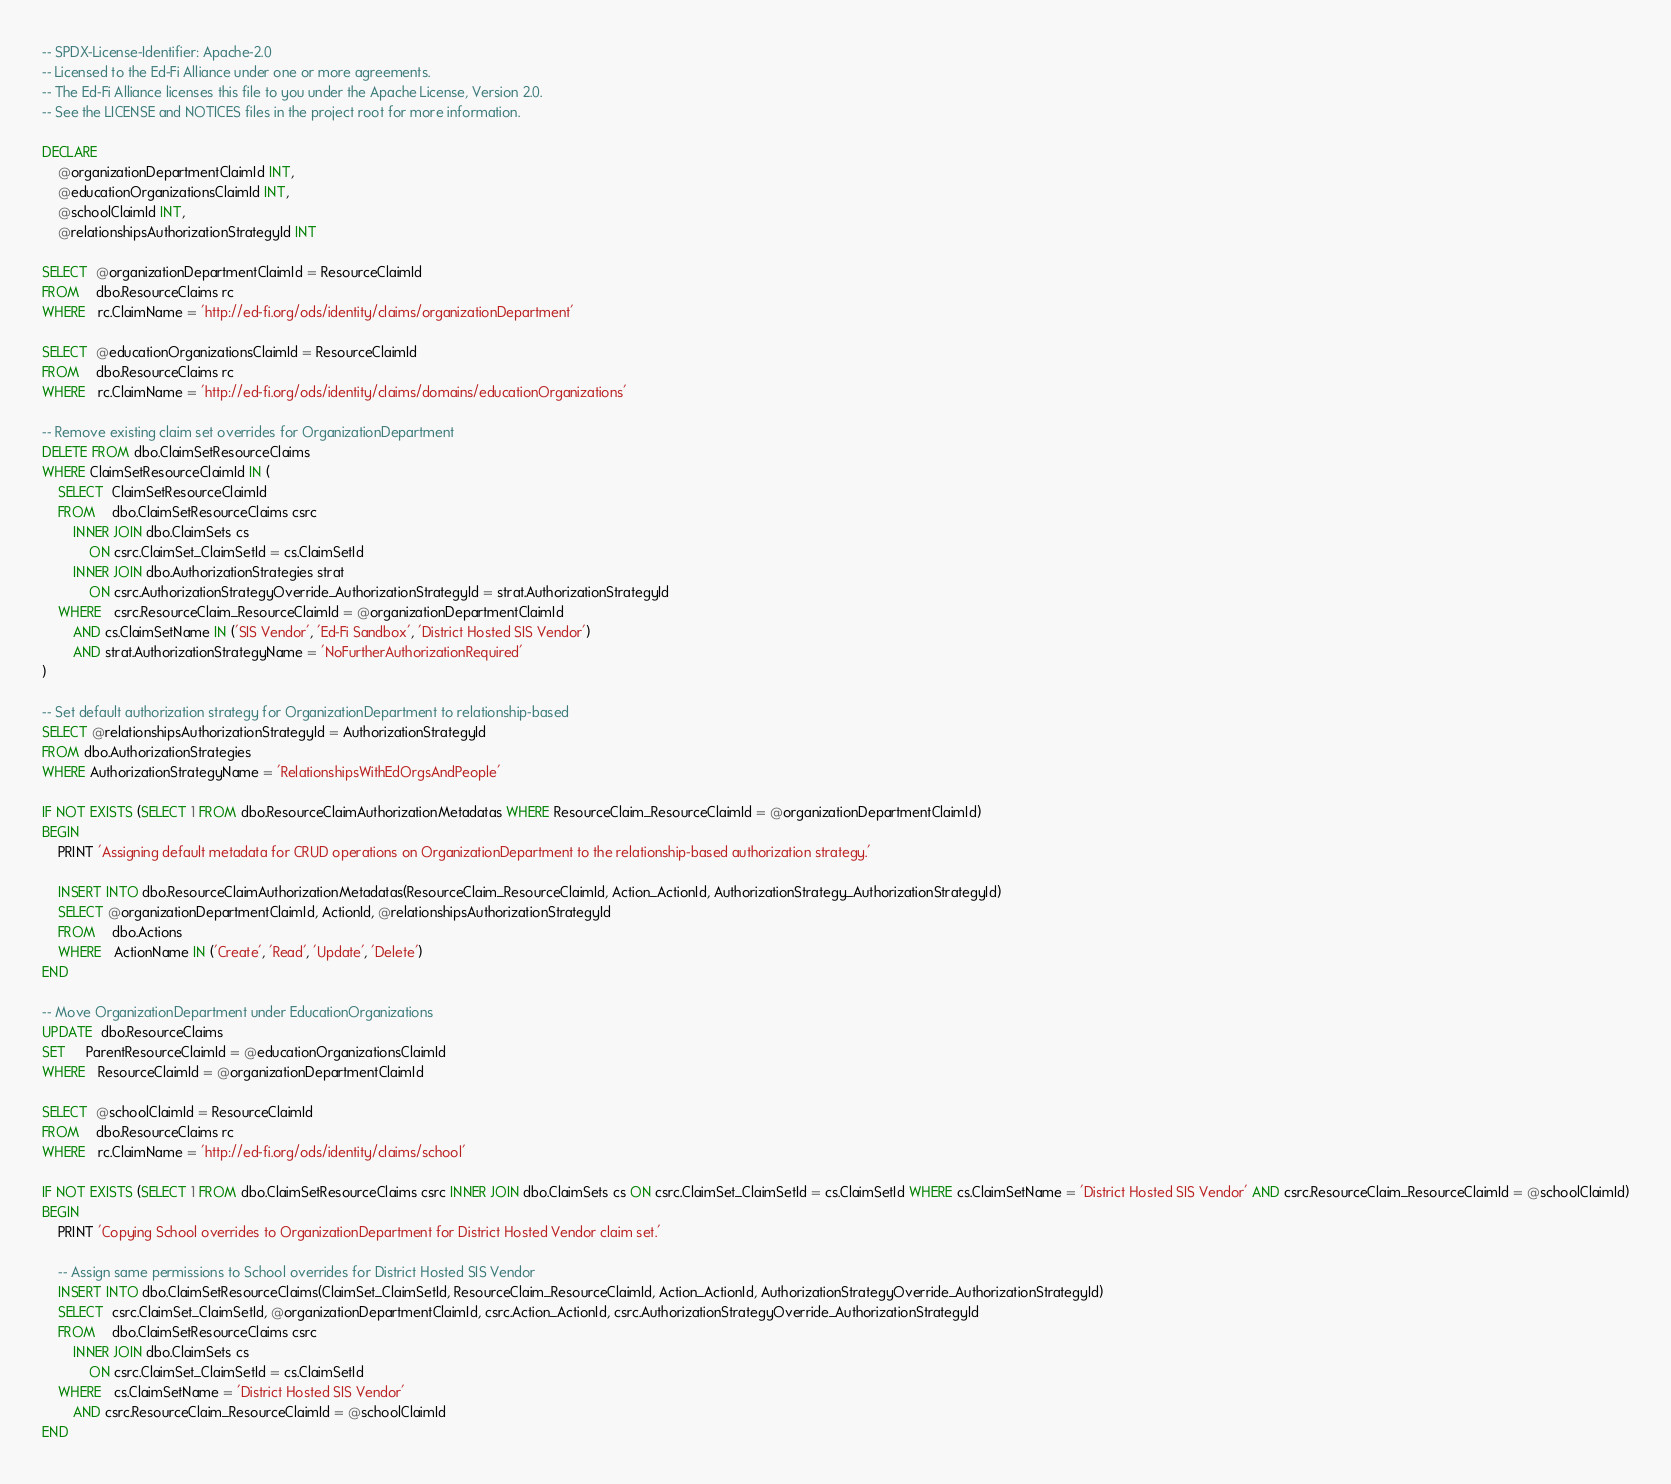<code> <loc_0><loc_0><loc_500><loc_500><_SQL_>-- SPDX-License-Identifier: Apache-2.0
-- Licensed to the Ed-Fi Alliance under one or more agreements.
-- The Ed-Fi Alliance licenses this file to you under the Apache License, Version 2.0.
-- See the LICENSE and NOTICES files in the project root for more information.

DECLARE 
    @organizationDepartmentClaimId INT,
    @educationOrganizationsClaimId INT,
    @schoolClaimId INT,
	@relationshipsAuthorizationStrategyId INT

SELECT  @organizationDepartmentClaimId = ResourceClaimId 
FROM    dbo.ResourceClaims rc 
WHERE   rc.ClaimName = 'http://ed-fi.org/ods/identity/claims/organizationDepartment'

SELECT  @educationOrganizationsClaimId = ResourceClaimId 
FROM    dbo.ResourceClaims rc 
WHERE   rc.ClaimName = 'http://ed-fi.org/ods/identity/claims/domains/educationOrganizations'

-- Remove existing claim set overrides for OrganizationDepartment
DELETE FROM dbo.ClaimSetResourceClaims
WHERE ClaimSetResourceClaimId IN (
    SELECT  ClaimSetResourceClaimId
    FROM    dbo.ClaimSetResourceClaims csrc
        INNER JOIN dbo.ClaimSets cs
            ON csrc.ClaimSet_ClaimSetId = cs.ClaimSetId
        INNER JOIN dbo.AuthorizationStrategies strat
            ON csrc.AuthorizationStrategyOverride_AuthorizationStrategyId = strat.AuthorizationStrategyId
    WHERE   csrc.ResourceClaim_ResourceClaimId = @organizationDepartmentClaimId
        AND cs.ClaimSetName IN ('SIS Vendor', 'Ed-Fi Sandbox', 'District Hosted SIS Vendor')
        AND strat.AuthorizationStrategyName = 'NoFurtherAuthorizationRequired'
)

-- Set default authorization strategy for OrganizationDepartment to relationship-based
SELECT @relationshipsAuthorizationStrategyId = AuthorizationStrategyId
FROM dbo.AuthorizationStrategies
WHERE AuthorizationStrategyName = 'RelationshipsWithEdOrgsAndPeople'

IF NOT EXISTS (SELECT 1 FROM dbo.ResourceClaimAuthorizationMetadatas WHERE ResourceClaim_ResourceClaimId = @organizationDepartmentClaimId)
BEGIN
    PRINT 'Assigning default metadata for CRUD operations on OrganizationDepartment to the relationship-based authorization strategy.'
    
    INSERT INTO dbo.ResourceClaimAuthorizationMetadatas(ResourceClaim_ResourceClaimId, Action_ActionId, AuthorizationStrategy_AuthorizationStrategyId)
    SELECT @organizationDepartmentClaimId, ActionId, @relationshipsAuthorizationStrategyId
    FROM    dbo.Actions
    WHERE   ActionName IN ('Create', 'Read', 'Update', 'Delete')
END

-- Move OrganizationDepartment under EducationOrganizations
UPDATE  dbo.ResourceClaims
SET     ParentResourceClaimId = @educationOrganizationsClaimId
WHERE   ResourceClaimId = @organizationDepartmentClaimId

SELECT  @schoolClaimId = ResourceClaimId 
FROM    dbo.ResourceClaims rc 
WHERE   rc.ClaimName = 'http://ed-fi.org/ods/identity/claims/school'

IF NOT EXISTS (SELECT 1 FROM dbo.ClaimSetResourceClaims csrc INNER JOIN dbo.ClaimSets cs ON csrc.ClaimSet_ClaimSetId = cs.ClaimSetId WHERE cs.ClaimSetName = 'District Hosted SIS Vendor' AND csrc.ResourceClaim_ResourceClaimId = @schoolClaimId)
BEGIN
    PRINT 'Copying School overrides to OrganizationDepartment for District Hosted Vendor claim set.'

    -- Assign same permissions to School overrides for District Hosted SIS Vendor
    INSERT INTO dbo.ClaimSetResourceClaims(ClaimSet_ClaimSetId, ResourceClaim_ResourceClaimId, Action_ActionId, AuthorizationStrategyOverride_AuthorizationStrategyId)
    SELECT  csrc.ClaimSet_ClaimSetId, @organizationDepartmentClaimId, csrc.Action_ActionId, csrc.AuthorizationStrategyOverride_AuthorizationStrategyId
    FROM    dbo.ClaimSetResourceClaims csrc
        INNER JOIN dbo.ClaimSets cs
            ON csrc.ClaimSet_ClaimSetId = cs.ClaimSetId
    WHERE   cs.ClaimSetName = 'District Hosted SIS Vendor'
        AND csrc.ResourceClaim_ResourceClaimId = @schoolClaimId 
END
</code> 